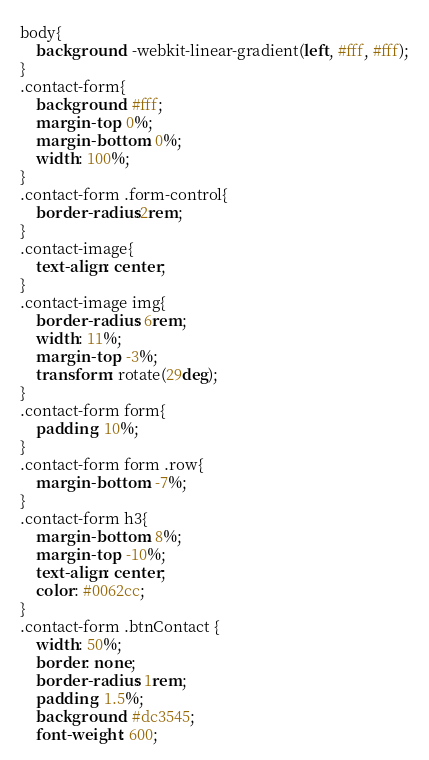Convert code to text. <code><loc_0><loc_0><loc_500><loc_500><_CSS_>body{
    background: -webkit-linear-gradient(left, #fff, #fff);
}
.contact-form{
    background: #fff;
    margin-top: 0%;
    margin-bottom: 0%;
    width: 100%;
}
.contact-form .form-control{
    border-radius:2rem;
}
.contact-image{
    text-align: center;
}
.contact-image img{
    border-radius: 6rem;
    width: 11%;
    margin-top: -3%;
    transform: rotate(29deg);
}
.contact-form form{
    padding: 10%;
}
.contact-form form .row{
    margin-bottom: -7%;
}
.contact-form h3{
    margin-bottom: 8%;
    margin-top: -10%;
    text-align: center;
    color: #0062cc;
}
.contact-form .btnContact {
    width: 50%;
    border: none;
    border-radius: 1rem;
    padding: 1.5%;
    background: #dc3545;
    font-weight: 600;</code> 